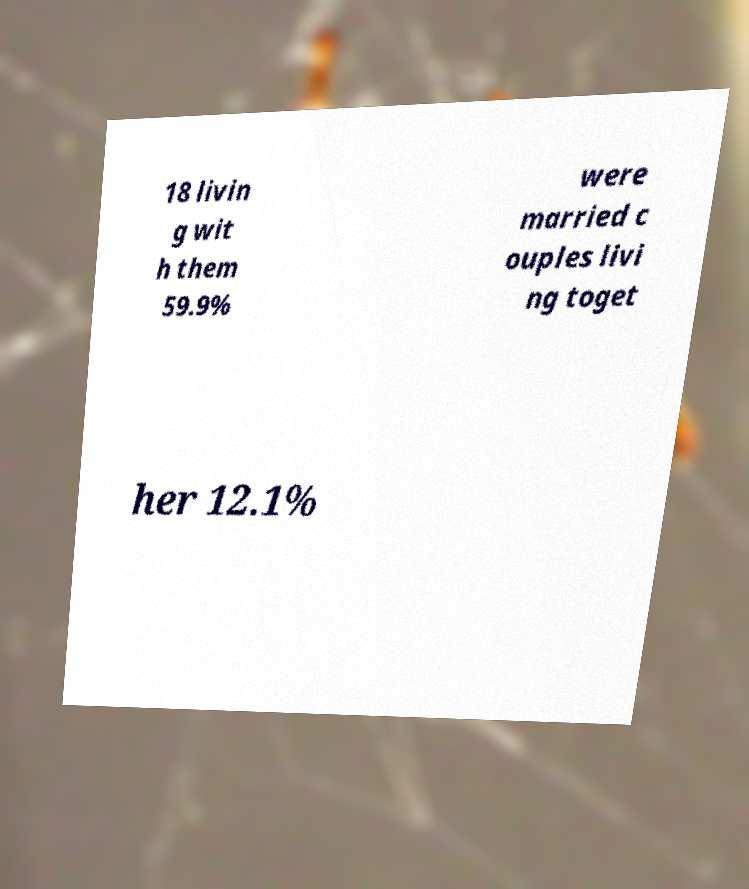For documentation purposes, I need the text within this image transcribed. Could you provide that? 18 livin g wit h them 59.9% were married c ouples livi ng toget her 12.1% 